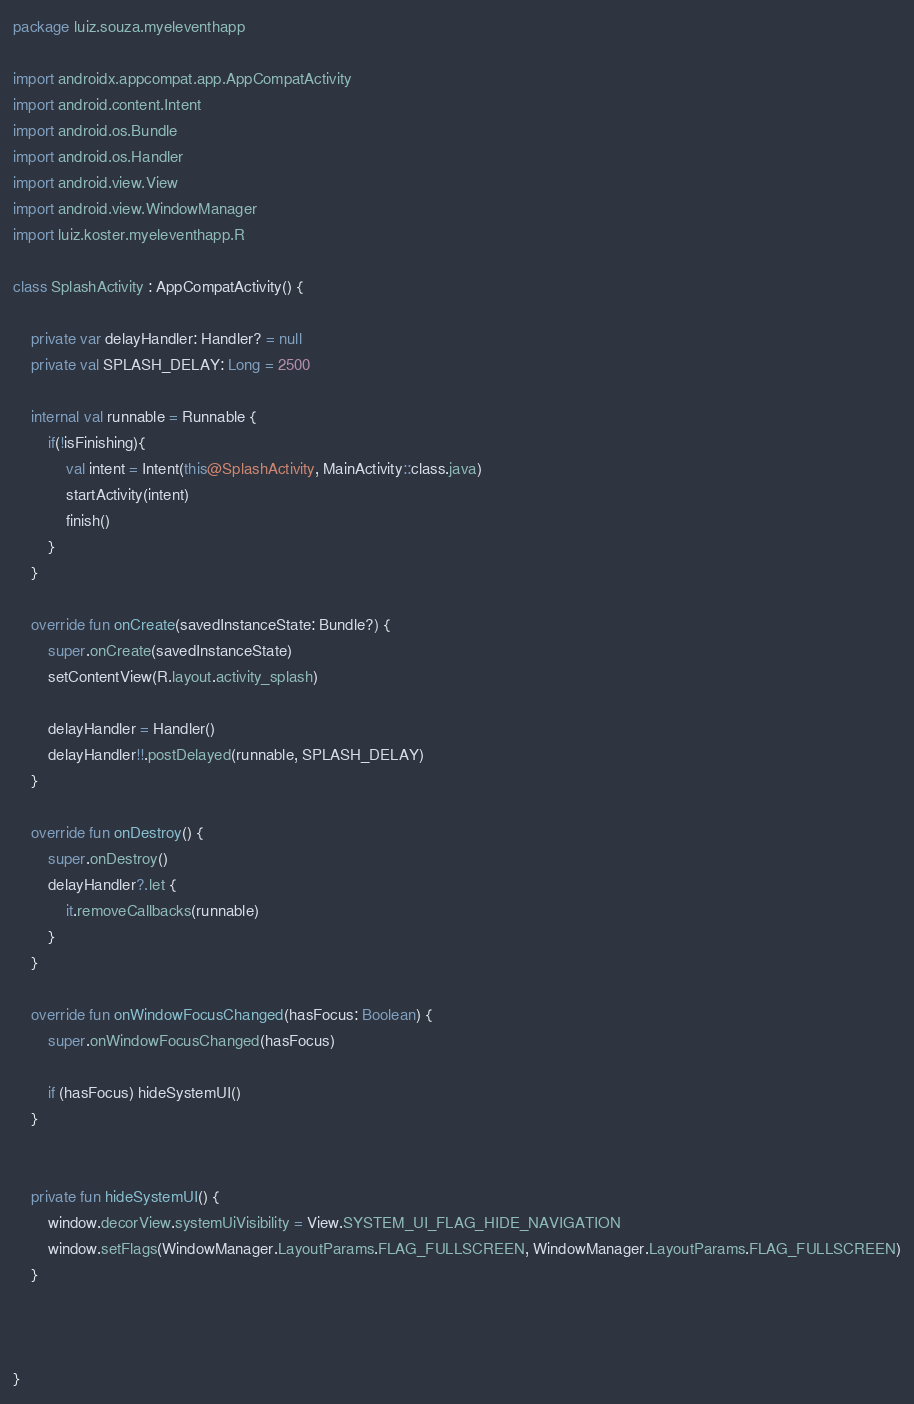<code> <loc_0><loc_0><loc_500><loc_500><_Kotlin_>package luiz.souza.myeleventhapp

import androidx.appcompat.app.AppCompatActivity
import android.content.Intent
import android.os.Bundle
import android.os.Handler
import android.view.View
import android.view.WindowManager
import luiz.koster.myeleventhapp.R

class SplashActivity : AppCompatActivity() {

    private var delayHandler: Handler? = null
    private val SPLASH_DELAY: Long = 2500

    internal val runnable = Runnable {
        if(!isFinishing){
            val intent = Intent(this@SplashActivity, MainActivity::class.java)
            startActivity(intent)
            finish()
        }
    }

    override fun onCreate(savedInstanceState: Bundle?) {
        super.onCreate(savedInstanceState)
        setContentView(R.layout.activity_splash)

        delayHandler = Handler()
        delayHandler!!.postDelayed(runnable, SPLASH_DELAY)
    }

    override fun onDestroy() {
        super.onDestroy()
        delayHandler?.let {
            it.removeCallbacks(runnable)
        }
    }

    override fun onWindowFocusChanged(hasFocus: Boolean) {
        super.onWindowFocusChanged(hasFocus)

        if (hasFocus) hideSystemUI()
    }


    private fun hideSystemUI() {
        window.decorView.systemUiVisibility = View.SYSTEM_UI_FLAG_HIDE_NAVIGATION
        window.setFlags(WindowManager.LayoutParams.FLAG_FULLSCREEN, WindowManager.LayoutParams.FLAG_FULLSCREEN)
    }



}</code> 